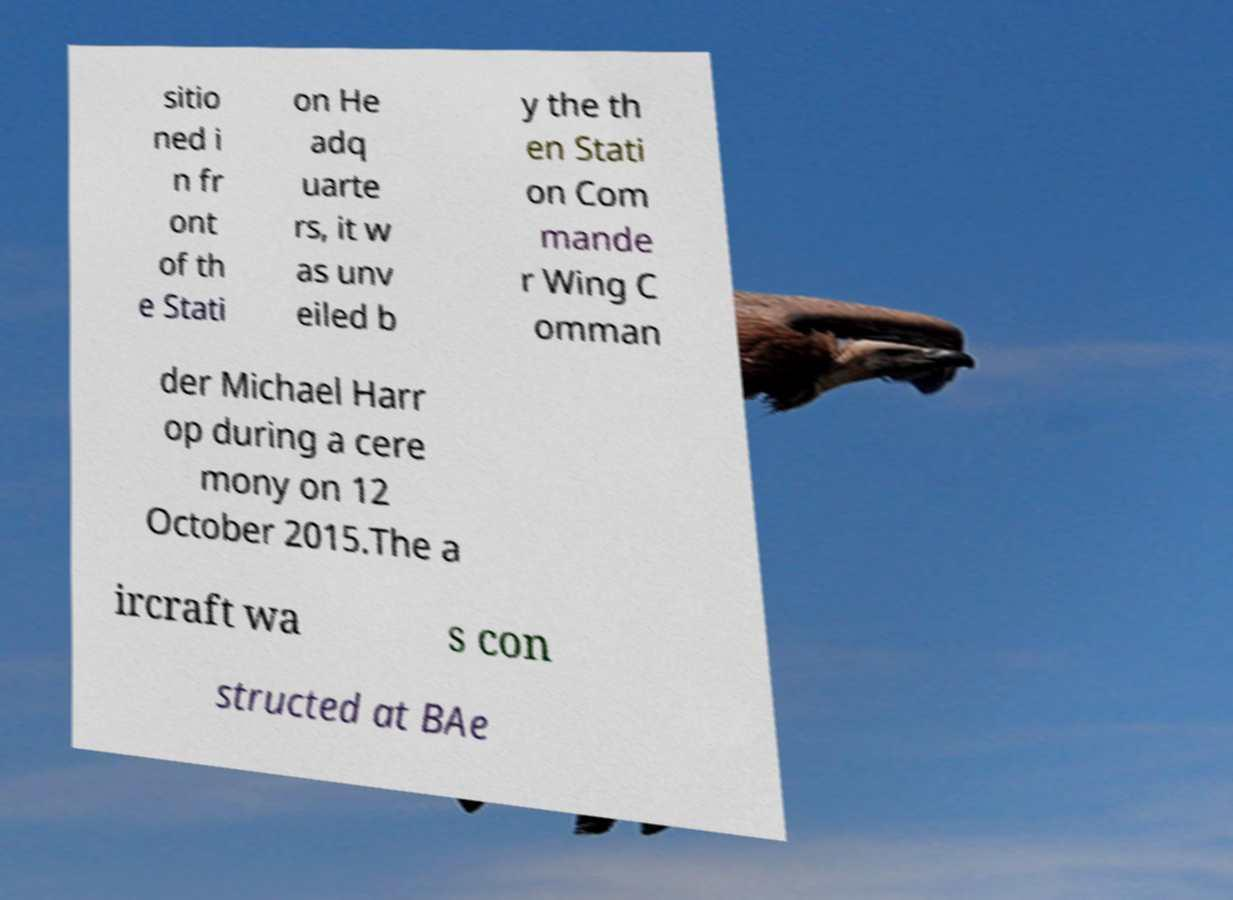Can you read and provide the text displayed in the image?This photo seems to have some interesting text. Can you extract and type it out for me? sitio ned i n fr ont of th e Stati on He adq uarte rs, it w as unv eiled b y the th en Stati on Com mande r Wing C omman der Michael Harr op during a cere mony on 12 October 2015.The a ircraft wa s con structed at BAe 